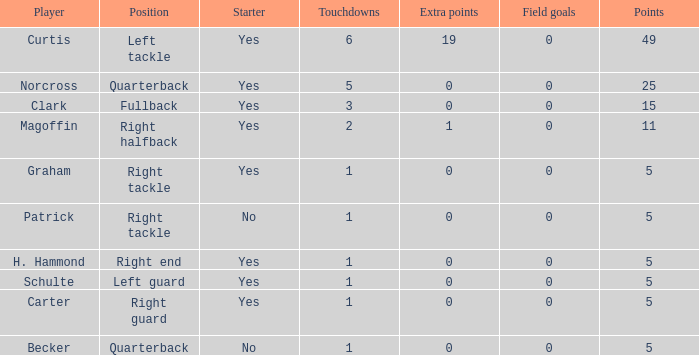Name the most field goals 0.0. 